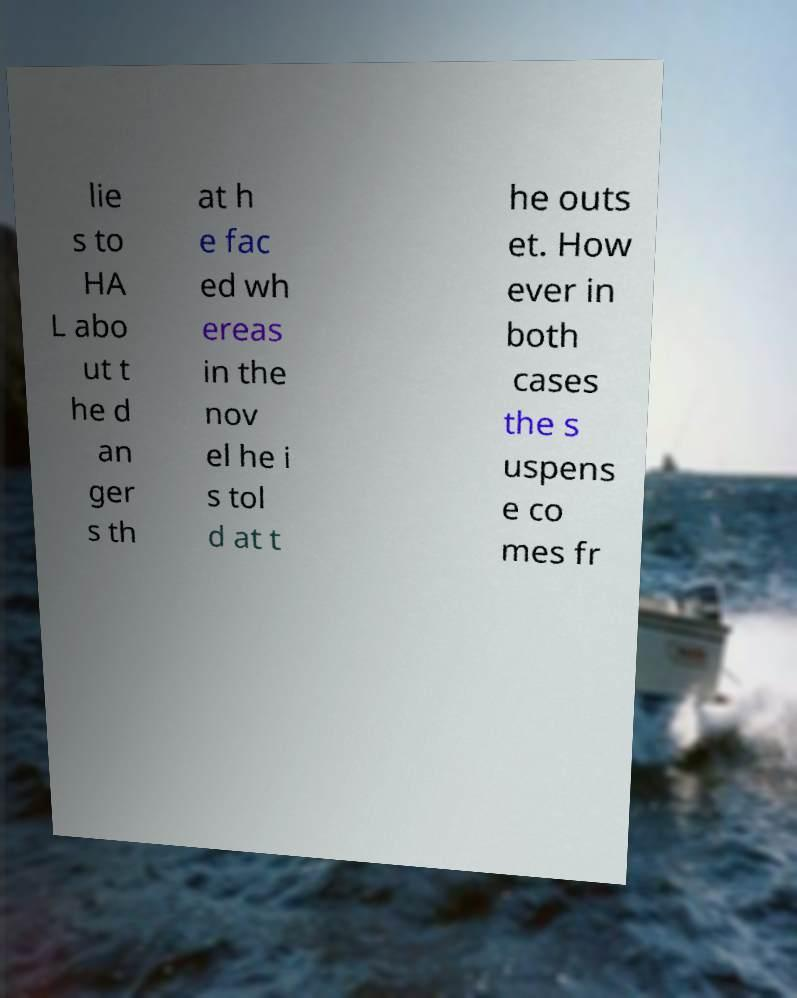I need the written content from this picture converted into text. Can you do that? lie s to HA L abo ut t he d an ger s th at h e fac ed wh ereas in the nov el he i s tol d at t he outs et. How ever in both cases the s uspens e co mes fr 